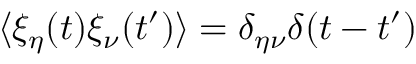<formula> <loc_0><loc_0><loc_500><loc_500>\langle \xi _ { \eta } ( t ) \xi _ { \nu } ( t ^ { \prime } ) \rangle = \delta _ { \eta \nu } \delta ( t - t ^ { \prime } )</formula> 